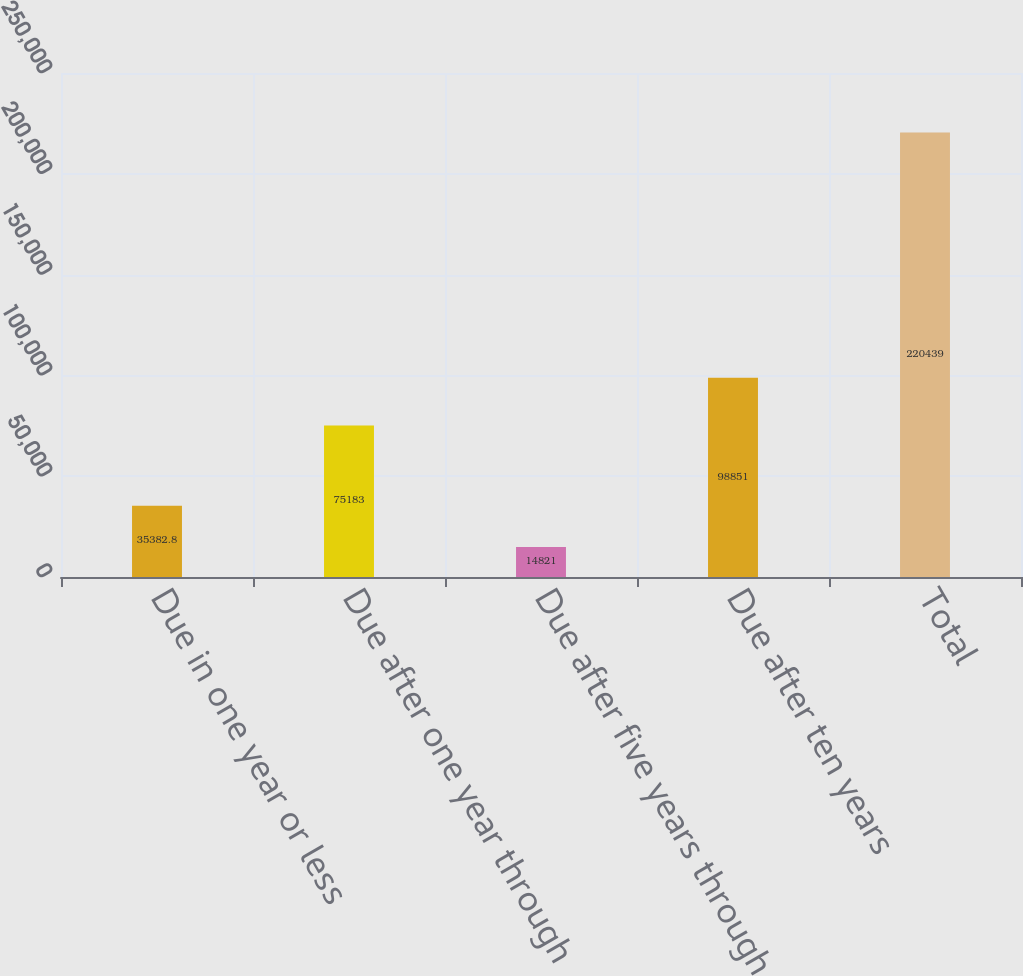<chart> <loc_0><loc_0><loc_500><loc_500><bar_chart><fcel>Due in one year or less<fcel>Due after one year through<fcel>Due after five years through<fcel>Due after ten years<fcel>Total<nl><fcel>35382.8<fcel>75183<fcel>14821<fcel>98851<fcel>220439<nl></chart> 